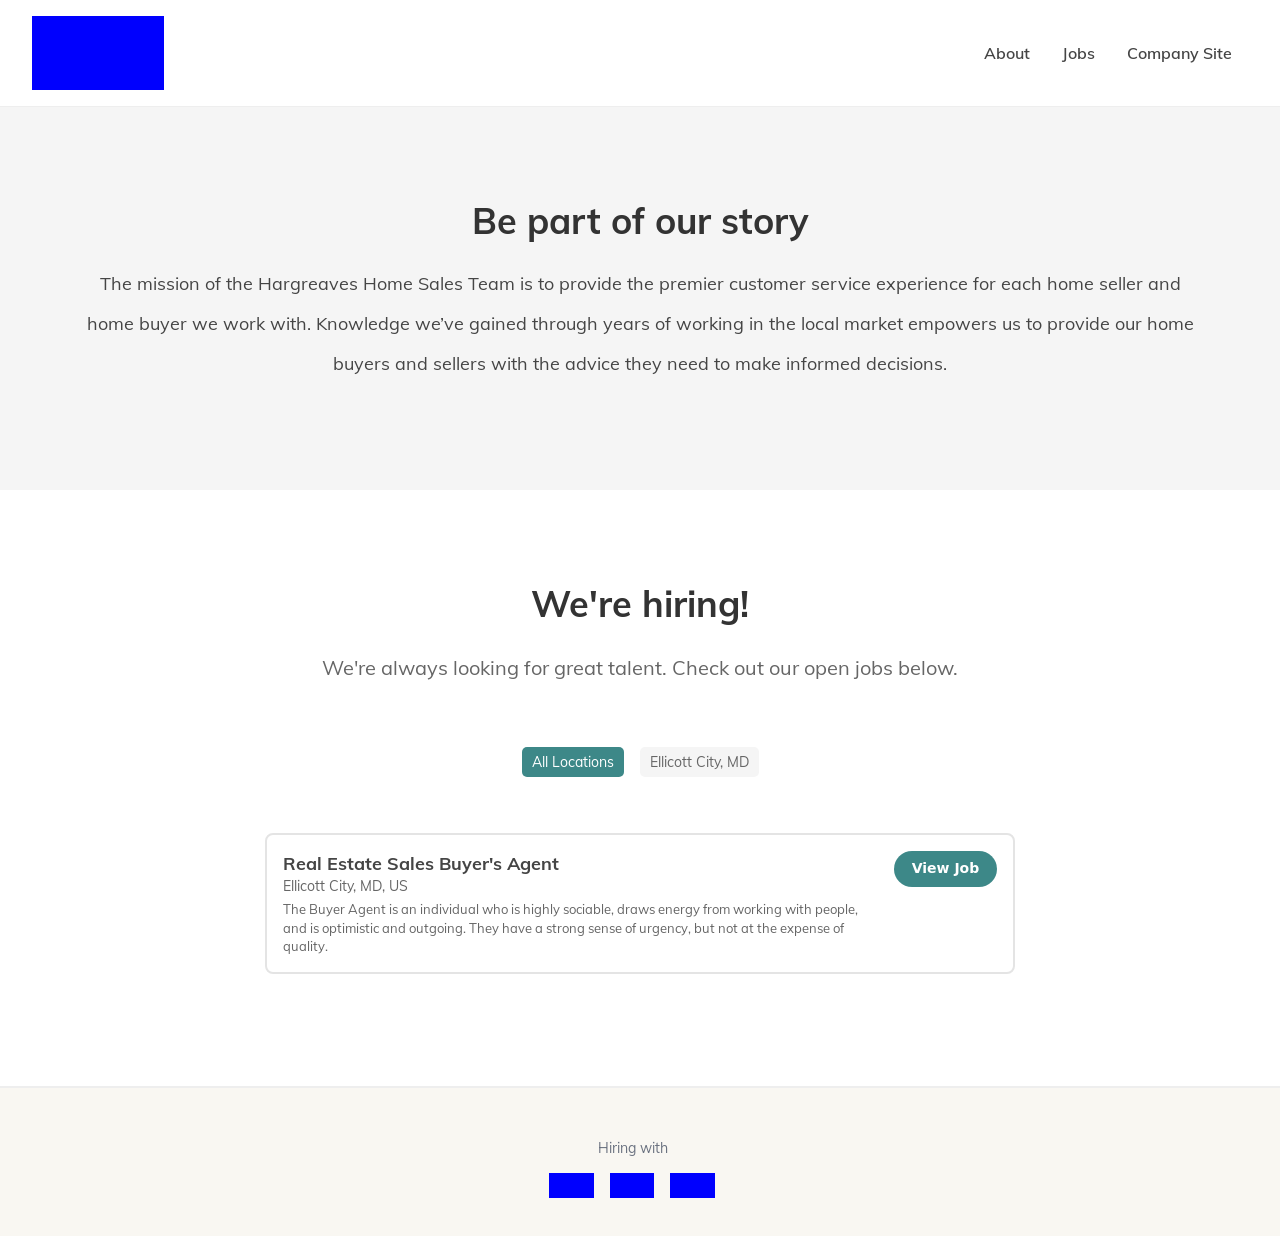Can you tell more about the company's mission as depicted in the image? The mission of the Hargreaves Home Sales Team is to provide a premier customer service experience to home buyers and sellers. They leverage years of local market experience to offer informed advice, helping clients make knowledgeable decisions. 